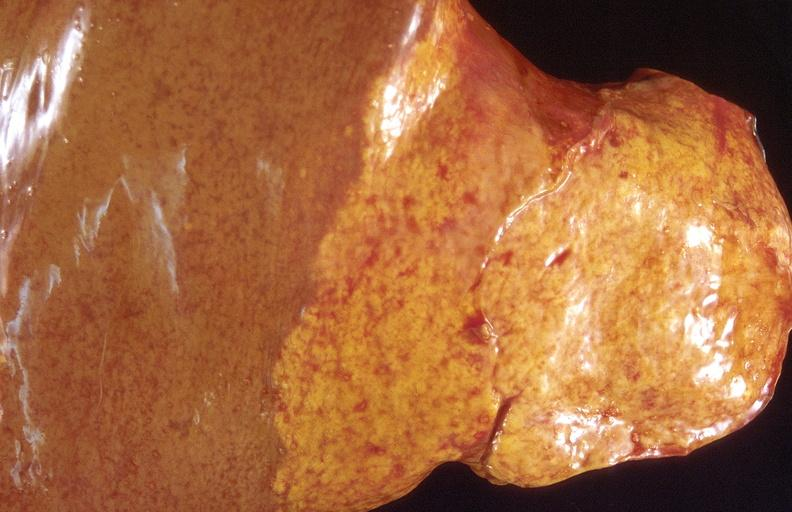s liver present?
Answer the question using a single word or phrase. Yes 